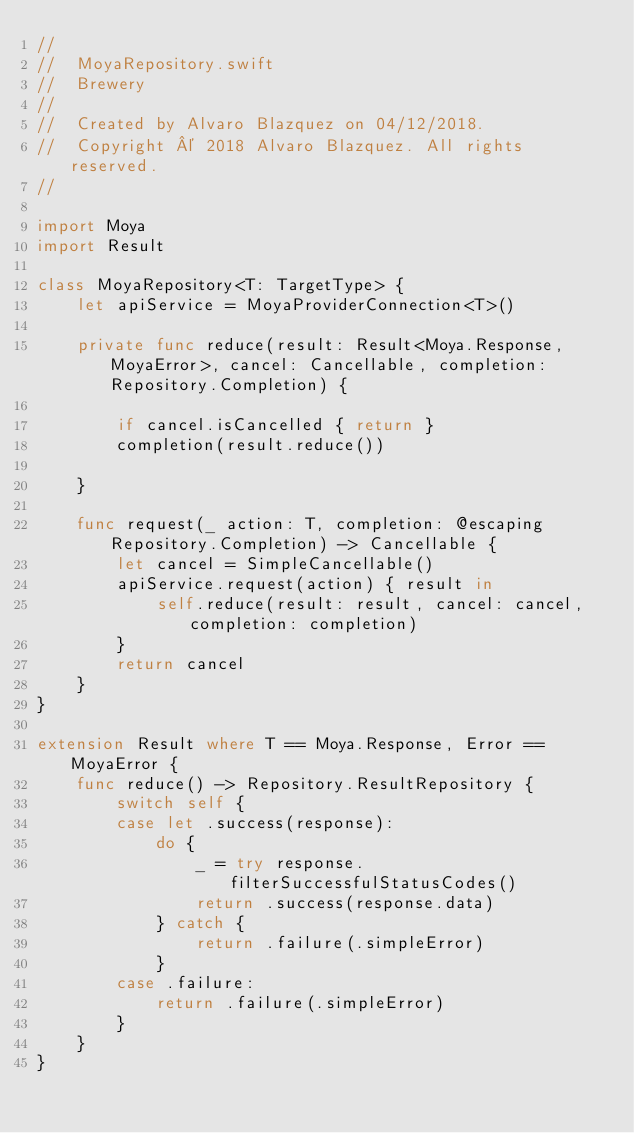Convert code to text. <code><loc_0><loc_0><loc_500><loc_500><_Swift_>//
//  MoyaRepository.swift
//  Brewery
//
//  Created by Alvaro Blazquez on 04/12/2018.
//  Copyright © 2018 Alvaro Blazquez. All rights reserved.
//

import Moya
import Result

class MoyaRepository<T: TargetType> {
    let apiService = MoyaProviderConnection<T>()
    
    private func reduce(result: Result<Moya.Response, MoyaError>, cancel: Cancellable, completion: Repository.Completion) {
        
        if cancel.isCancelled { return }
        completion(result.reduce())
        
    }
    
    func request(_ action: T, completion: @escaping Repository.Completion) -> Cancellable {
        let cancel = SimpleCancellable()
        apiService.request(action) { result in
            self.reduce(result: result, cancel: cancel, completion: completion)
        }
        return cancel
    }
}

extension Result where T == Moya.Response, Error == MoyaError {
    func reduce() -> Repository.ResultRepository {
        switch self {
        case let .success(response):
            do {
                _ = try response.filterSuccessfulStatusCodes()
                return .success(response.data)
            } catch {
                return .failure(.simpleError)
            }
        case .failure:
            return .failure(.simpleError)
        }
    }
}
</code> 